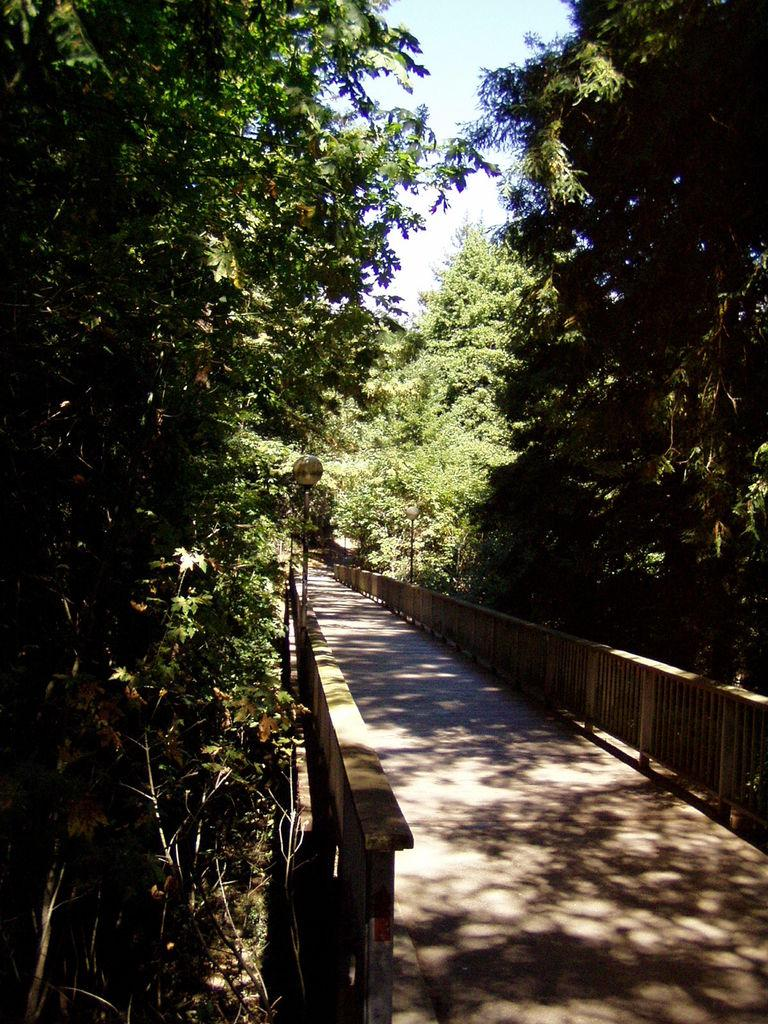What is the main structure in the foreground of the image? There is a bridge in the foreground of the image. What type of vegetation is present on either side of the bridge? There are trees on either side of the bridge. What other structures are present on either side of the bridge? There are poles on either side of the bridge. What is visible at the top of the image? The sky is visible at the top of the image. What type of gate can be seen on the bridge in the image? There is no gate present on the bridge in the image. How does the bridge get crushed in the image? The bridge does not get crushed in the image; it appears to be intact and in use. 